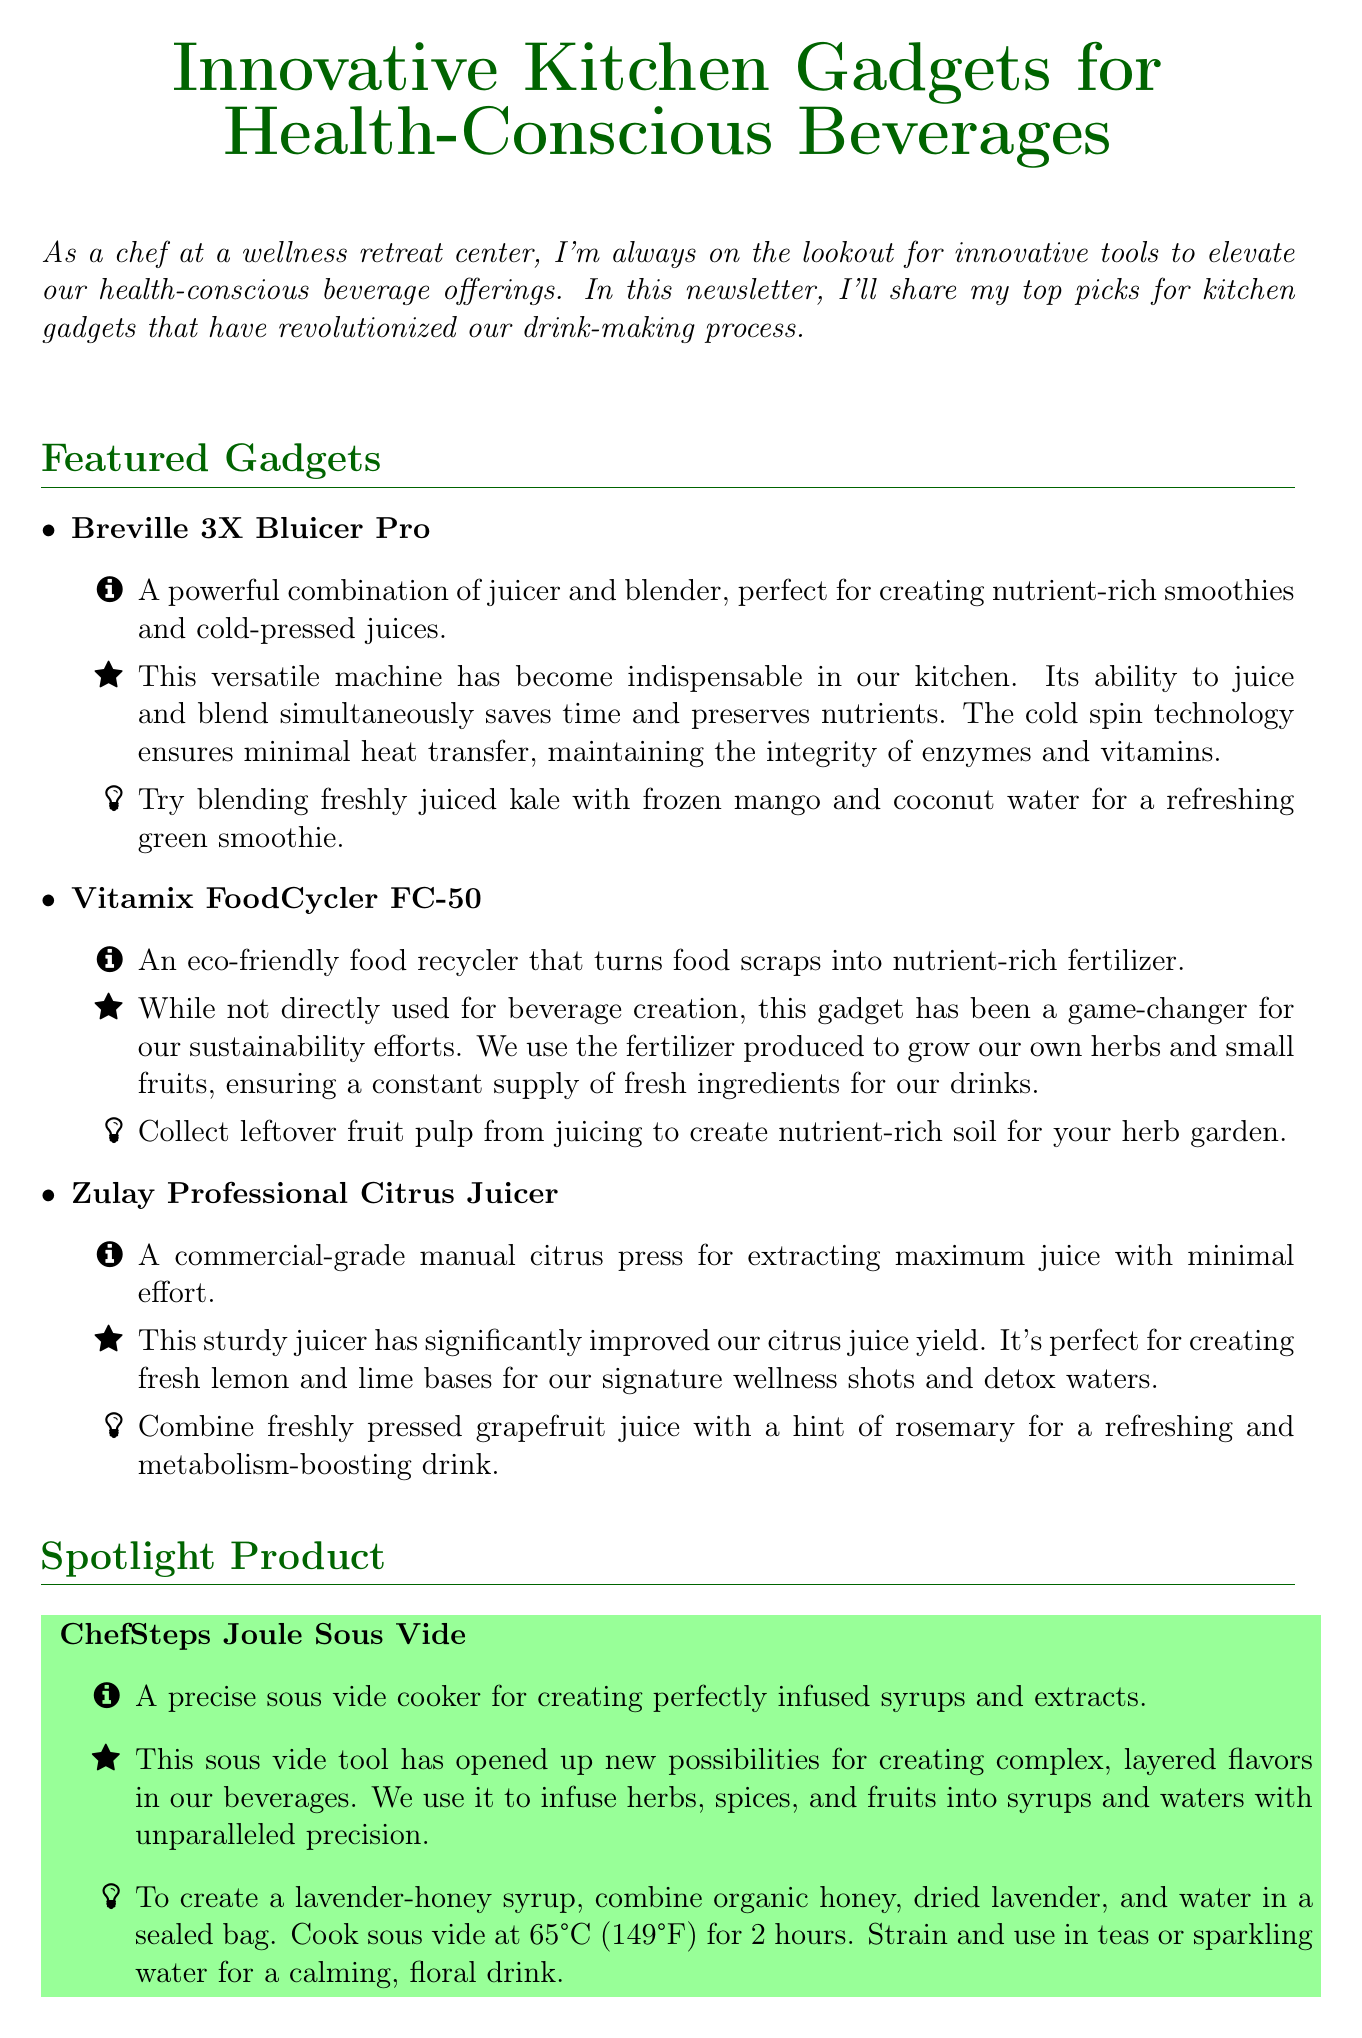what is the title of the newsletter? The title of the newsletter is highlighted at the beginning of the document.
Answer: Innovative Kitchen Gadgets for Health-Conscious Beverages how many featured gadgets are listed? The number of featured gadgets is counted in the section listing them.
Answer: three what is the spotlight product? The spotlight product is mentioned in a dedicated section of the newsletter.
Answer: ChefSteps Joule Sous Vide what type of blender is the budget-friendly option? The budget-friendly option is clearly labeled under its specific section.
Answer: personal what is a usage demonstration for the ChefSteps Joule Sous Vide? The document provides a specific cooking demonstration for the spotlight product.
Answer: To create a lavender-honey syrup, combine organic honey, dried lavender, and water in a sealed bag. Cook sous vide at 65°C (149°F) for 2 hours. Strain and use in teas or sparkling water for a calming, floral drink why is the Vitamix FoodCycler FC-50 significant for sustainability? This reasoning explores multiple pieces of information related to sustainability within the document.
Answer: It turns food scraps into nutrient-rich fertilizer which gadget helps eliminate single-use plastics? The specific gadget addressing this issue is mentioned under its section.
Answer: Stainless Steel Reusable Straws Set by Klean Kanteen what is a usage tip for the Zulay Professional Citrus Juicer? Each gadget includes usage tips relevant to their function.
Answer: Combine freshly pressed grapefruit juice with a hint of rosemary for a refreshing and metabolism-boosting drink 